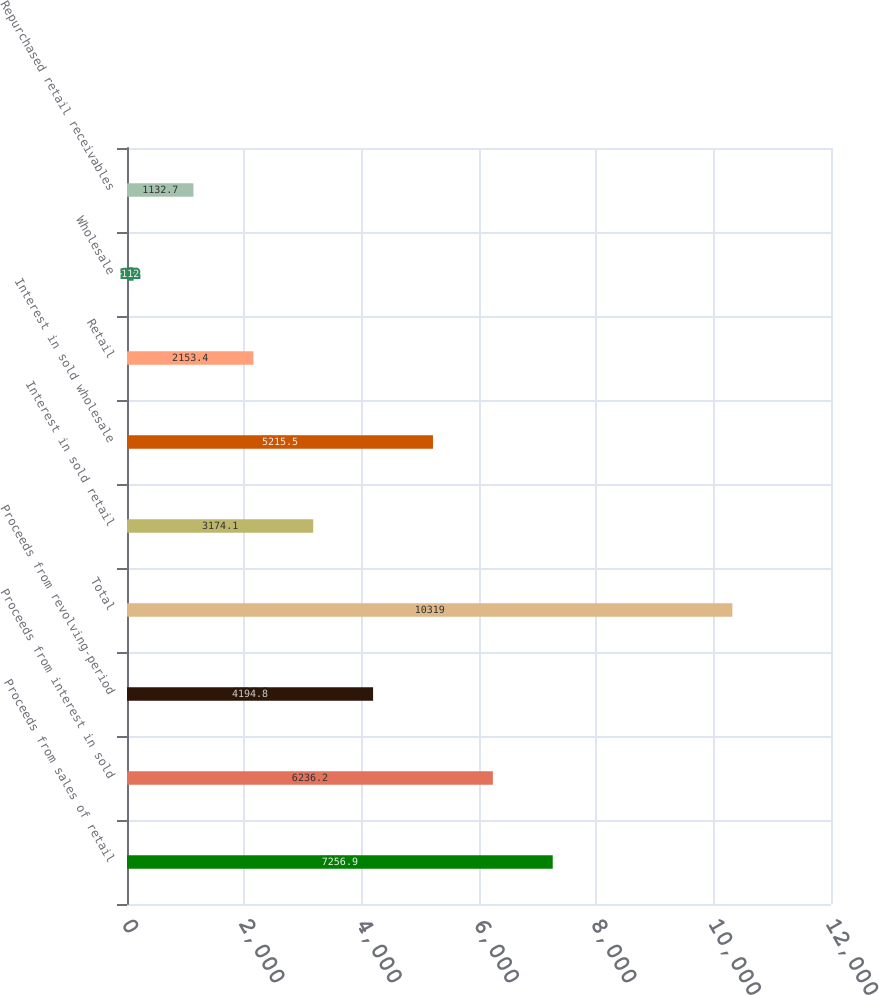<chart> <loc_0><loc_0><loc_500><loc_500><bar_chart><fcel>Proceeds from sales of retail<fcel>Proceeds from interest in sold<fcel>Proceeds from revolving-period<fcel>Total<fcel>Interest in sold retail<fcel>Interest in sold wholesale<fcel>Retail<fcel>Wholesale<fcel>Repurchased retail receivables<nl><fcel>7256.9<fcel>6236.2<fcel>4194.8<fcel>10319<fcel>3174.1<fcel>5215.5<fcel>2153.4<fcel>112<fcel>1132.7<nl></chart> 